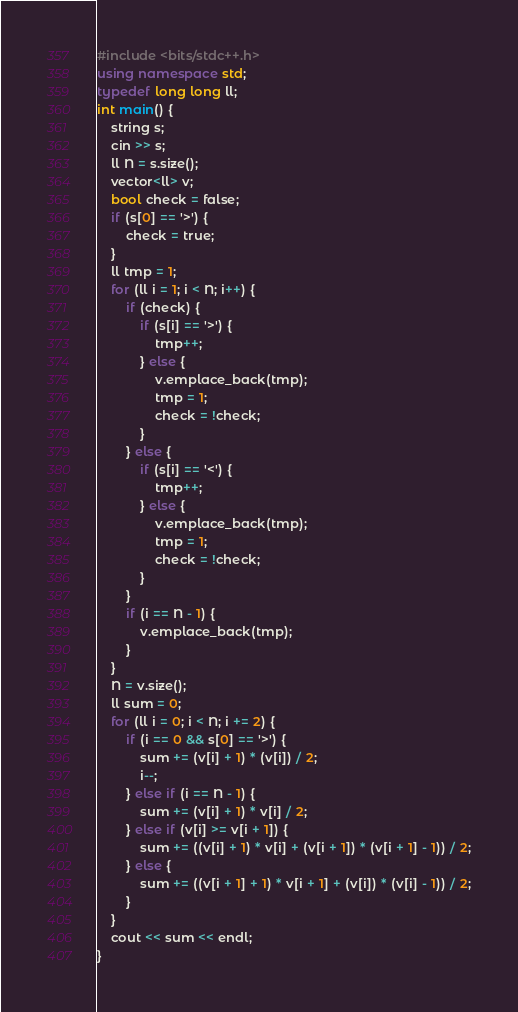<code> <loc_0><loc_0><loc_500><loc_500><_C++_>#include <bits/stdc++.h>
using namespace std;
typedef long long ll;
int main() {
    string s;
    cin >> s;
    ll N = s.size();
    vector<ll> v;
    bool check = false;
    if (s[0] == '>') {
        check = true;
    }
    ll tmp = 1;
    for (ll i = 1; i < N; i++) {
        if (check) {
            if (s[i] == '>') {
                tmp++;
            } else {
                v.emplace_back(tmp);
                tmp = 1;
                check = !check;
            }
        } else {
            if (s[i] == '<') {
                tmp++;
            } else {
                v.emplace_back(tmp);
                tmp = 1;
                check = !check;
            }
        }
        if (i == N - 1) {
            v.emplace_back(tmp);
        }
    }
    N = v.size();
    ll sum = 0;
    for (ll i = 0; i < N; i += 2) {
        if (i == 0 && s[0] == '>') {
            sum += (v[i] + 1) * (v[i]) / 2;
            i--;
        } else if (i == N - 1) {
            sum += (v[i] + 1) * v[i] / 2;
        } else if (v[i] >= v[i + 1]) {
            sum += ((v[i] + 1) * v[i] + (v[i + 1]) * (v[i + 1] - 1)) / 2;
        } else {
            sum += ((v[i + 1] + 1) * v[i + 1] + (v[i]) * (v[i] - 1)) / 2;
        }
    }
    cout << sum << endl;
}</code> 